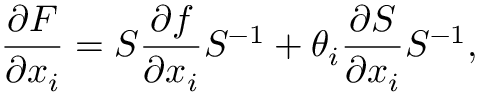<formula> <loc_0><loc_0><loc_500><loc_500>\frac { \partial F } { \partial x _ { i } } = S \frac { \partial f } { \partial x _ { i } } S ^ { - 1 } + \theta _ { i } \frac { \partial S } { \partial x _ { i } } S ^ { - 1 } ,</formula> 